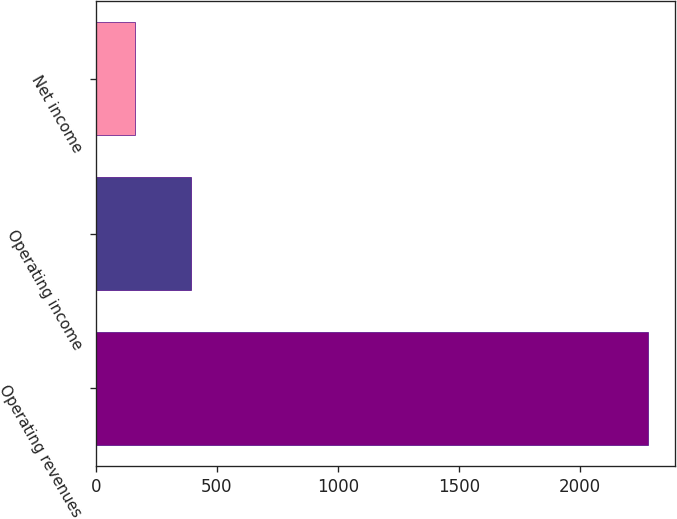<chart> <loc_0><loc_0><loc_500><loc_500><bar_chart><fcel>Operating revenues<fcel>Operating income<fcel>Net income<nl><fcel>2281<fcel>392<fcel>161<nl></chart> 